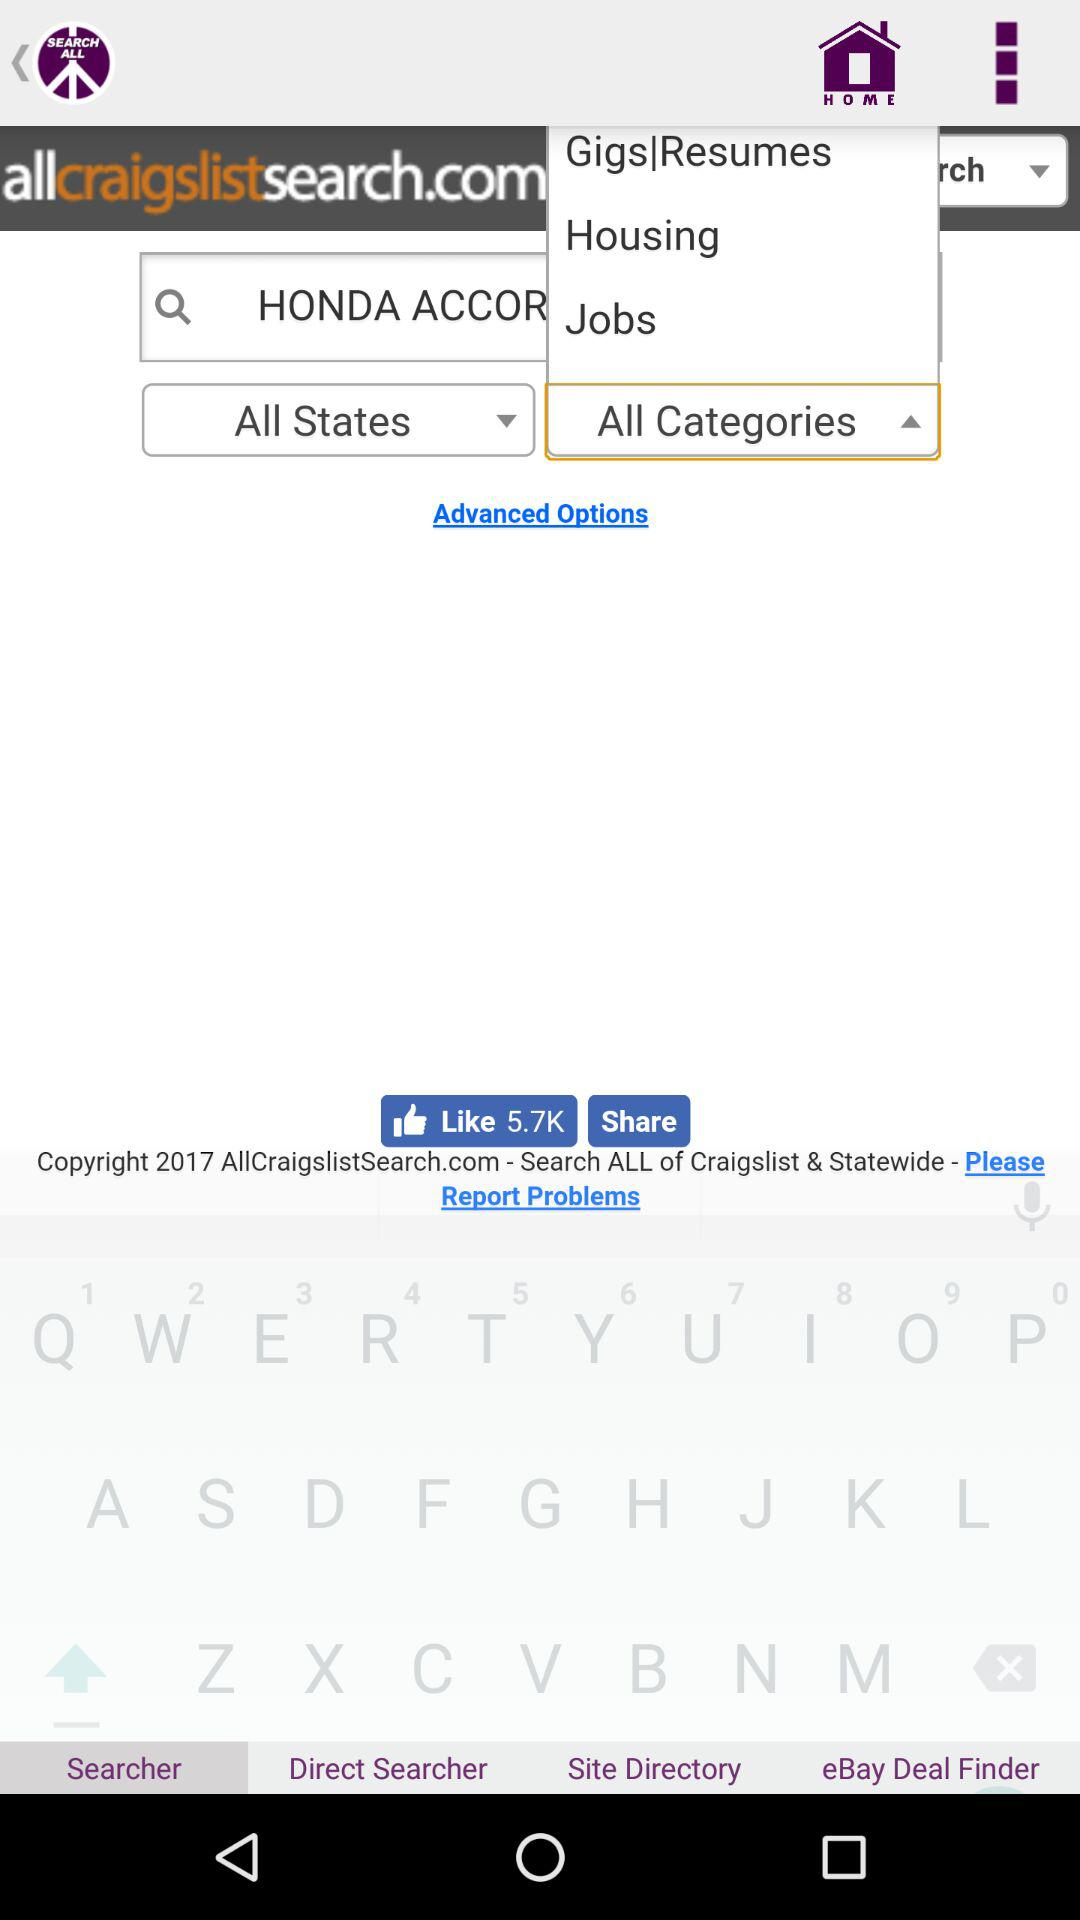What is the number of likes? The number of likes is 5.7k. 